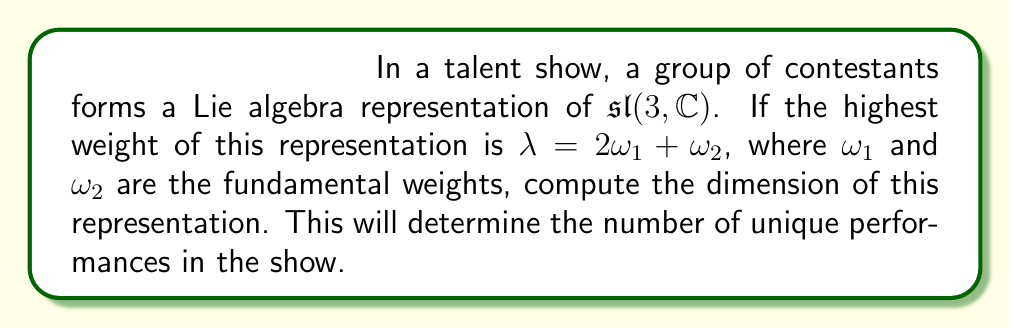Provide a solution to this math problem. To compute the dimension of a Lie algebra representation, we can use the Weyl dimension formula. For $\mathfrak{sl}(3, \mathbb{C})$, the formula is:

$$\dim V_\lambda = \frac{(\lambda + \rho, \alpha_1 + \alpha_2)(\lambda + \rho, \alpha_1)(\lambda + \rho, \alpha_2)}{(\rho, \alpha_1 + \alpha_2)(\rho, \alpha_1)(\rho, \alpha_2)}$$

where $\lambda$ is the highest weight, $\rho$ is half the sum of positive roots, and $\alpha_1, \alpha_2$ are the simple roots.

Steps:
1) For $\mathfrak{sl}(3, \mathbb{C})$, we have:
   $\alpha_1 = 2\omega_1 - \omega_2$
   $\alpha_2 = -\omega_1 + 2\omega_2$
   $\rho = \omega_1 + \omega_2$

2) Given $\lambda = 2\omega_1 + \omega_2$, we calculate $\lambda + \rho$:
   $\lambda + \rho = (2\omega_1 + \omega_2) + (\omega_1 + \omega_2) = 3\omega_1 + 2\omega_2$

3) Now, let's compute the inner products:
   $(\lambda + \rho, \alpha_1 + \alpha_2) = (3\omega_1 + 2\omega_2, \omega_1 + \omega_2) = 5$
   $(\lambda + \rho, \alpha_1) = (3\omega_1 + 2\omega_2, 2\omega_1 - \omega_2) = 4$
   $(\lambda + \rho, \alpha_2) = (3\omega_1 + 2\omega_2, -\omega_1 + 2\omega_2) = 4$
   
   $(\rho, \alpha_1 + \alpha_2) = (\omega_1 + \omega_2, \omega_1 + \omega_2) = 2$
   $(\rho, \alpha_1) = (\omega_1 + \omega_2, 2\omega_1 - \omega_2) = 1$
   $(\rho, \alpha_2) = (\omega_1 + \omega_2, -\omega_1 + 2\omega_2) = 1$

4) Substituting into the Weyl dimension formula:

   $$\dim V_\lambda = \frac{5 \cdot 4 \cdot 4}{2 \cdot 1 \cdot 1} = 40$$

Therefore, the dimension of the representation is 40.
Answer: The dimension of the representation is 40. 